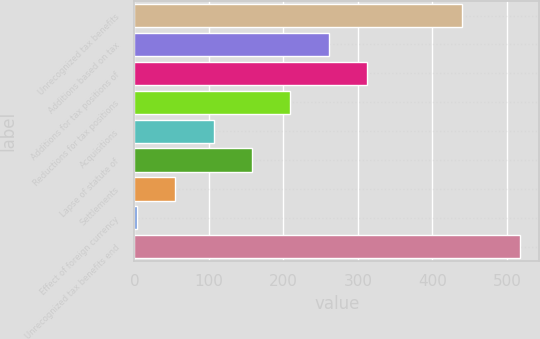Convert chart. <chart><loc_0><loc_0><loc_500><loc_500><bar_chart><fcel>Unrecognized tax benefits<fcel>Additions based on tax<fcel>Additions for tax positions of<fcel>Reductions for tax positions<fcel>Acquisitions<fcel>Lapse of statute of<fcel>Settlements<fcel>Effect of foreign currency<fcel>Unrecognized tax benefits end<nl><fcel>439.3<fcel>260.65<fcel>312.02<fcel>209.28<fcel>106.54<fcel>157.91<fcel>55.17<fcel>3.8<fcel>517.5<nl></chart> 